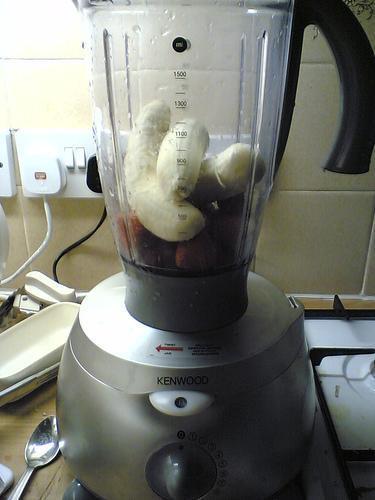How many bananas are in the photo?
Give a very brief answer. 3. How many people are between the two orange buses in the image?
Give a very brief answer. 0. 